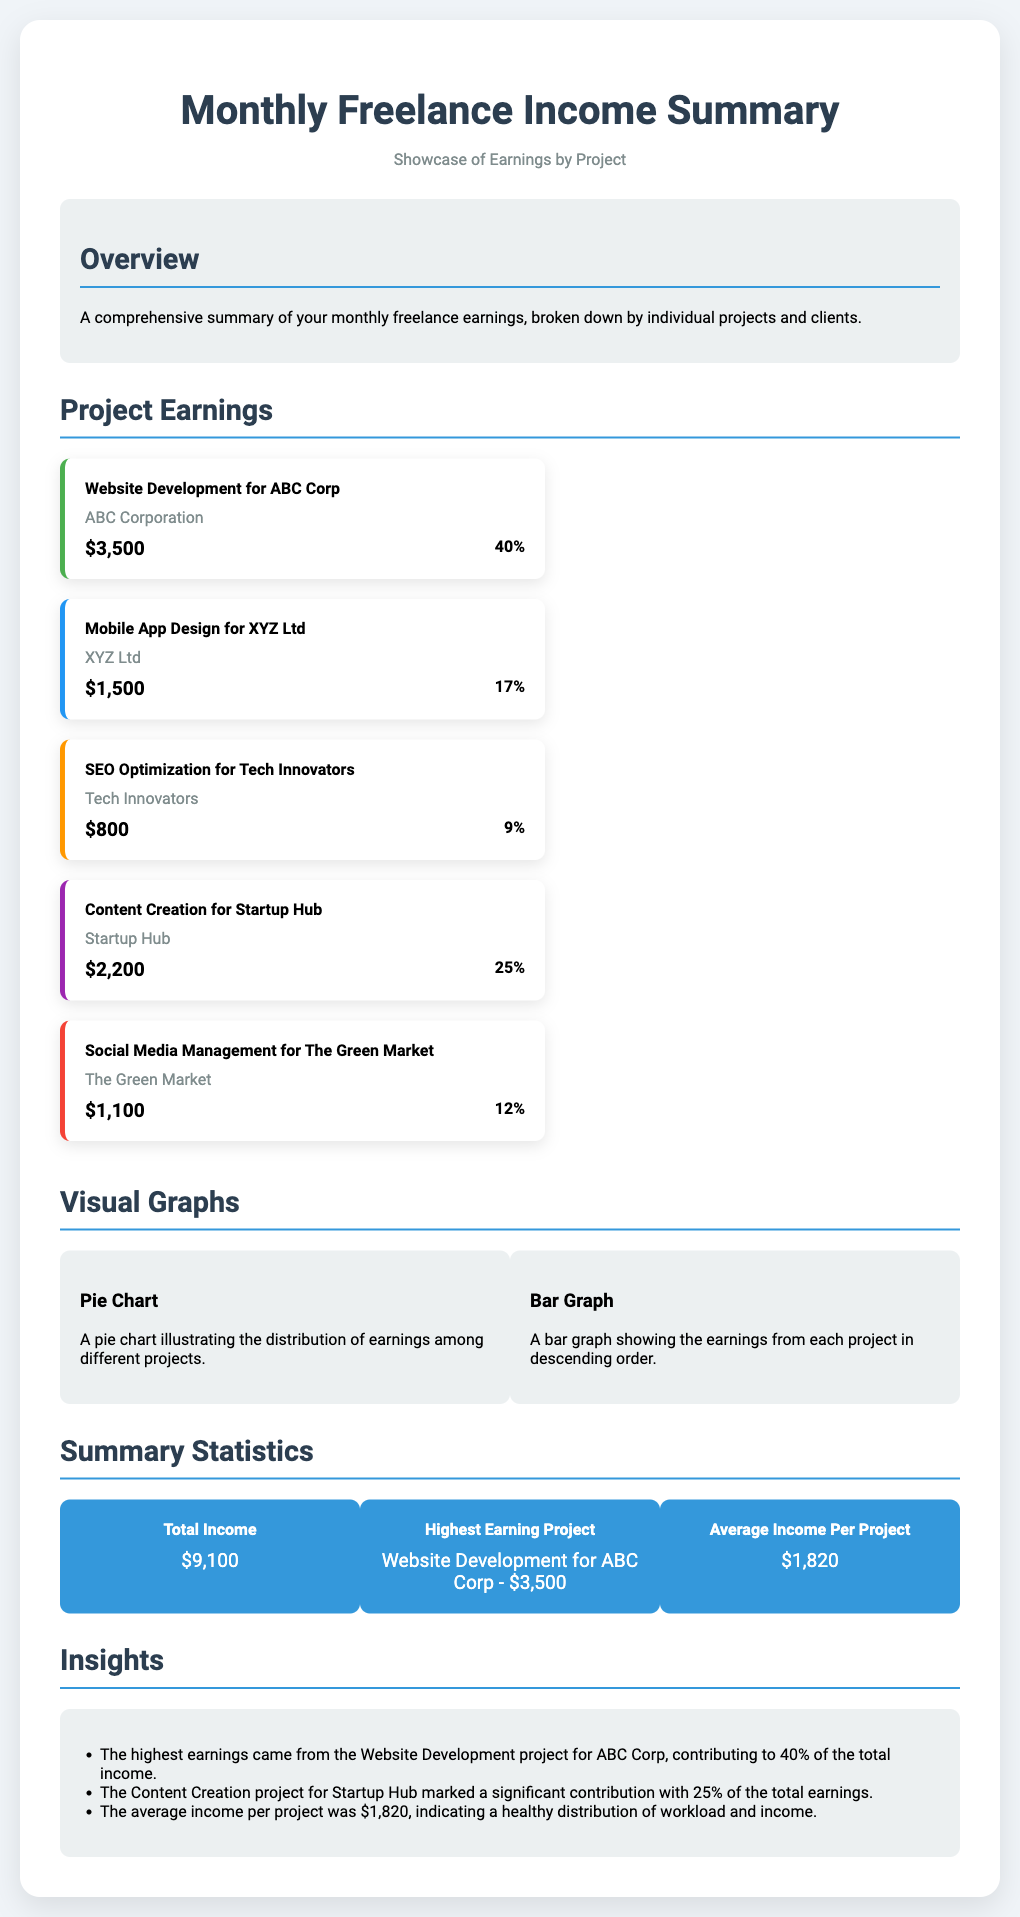What is the total income? The total income is explicitly stated in the summary statistics section of the document.
Answer: $9,100 What project earned the highest amount? The information regarding the highest earning project is detailed in the summary statistics section.
Answer: Website Development for ABC Corp - $3,500 What percentage of the total income came from the Mobile App Design project? The document provides the percentage of income for each project, specifically for the Mobile App Design project.
Answer: 17% Which client is associated with the project on SEO Optimization? The document lists all projects along with their respective clients, including the one for SEO Optimization.
Answer: Tech Innovators How many projects contributed to the earnings summary? The document outlines multiple projects, and counting them provides a total number.
Answer: 5 What is the average income per project? The average income per project is calculated and stated in the summary statistics section.
Answer: $1,820 Which project accounted for 25% of the total earnings? The document specifies the percentage contribution of each project, indicating the one with 25%.
Answer: Content Creation for Startup Hub What type of graphs are included in the visual section? The document mentions the types of visual aids used to represent the earnings data.
Answer: Pie Chart and Bar Graph 